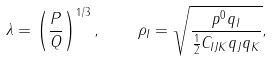Convert formula to latex. <formula><loc_0><loc_0><loc_500><loc_500>\lambda = \left ( \frac { P } { Q } \right ) ^ { 1 / 3 } , \quad \rho _ { I } = \sqrt { \frac { p ^ { 0 } q _ { I } } { \frac { 1 } { 2 } C _ { I J K } q _ { J } q _ { K } } } ,</formula> 